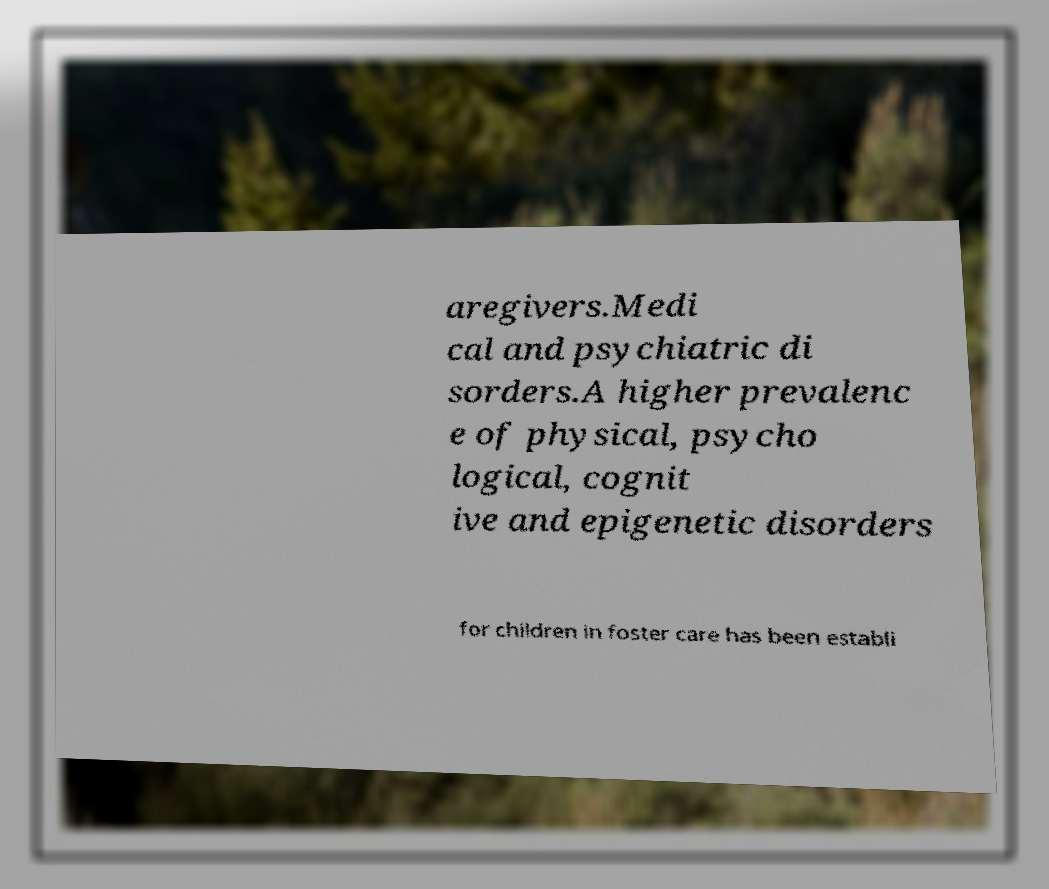What messages or text are displayed in this image? I need them in a readable, typed format. aregivers.Medi cal and psychiatric di sorders.A higher prevalenc e of physical, psycho logical, cognit ive and epigenetic disorders for children in foster care has been establi 